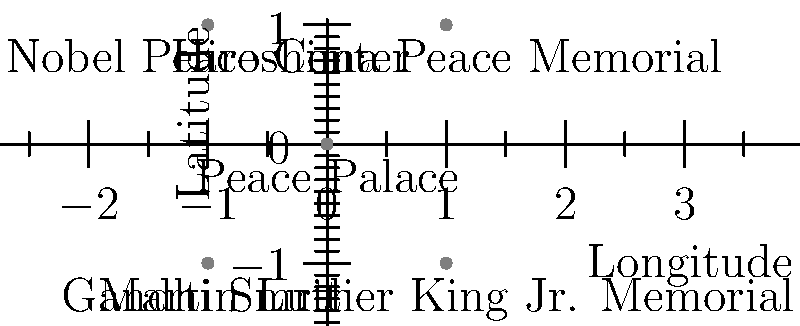Identify the landmark located at coordinates (0,0) on the graph, which is associated with international peace efforts and housed the Permanent Court of Arbitration. To answer this question, let's analyze the graph step-by-step:

1. The graph shows five landmarks associated with peace movements plotted on a coordinate system.
2. Each landmark is represented by a gray circle with its name labeled below.
3. We need to focus on the landmark at coordinates (0,0), which is at the origin of the graph.
4. The landmark at (0,0) is labeled "Peace Palace".
5. The Peace Palace, located in The Hague, Netherlands, is indeed associated with international peace efforts.
6. It houses the Permanent Court of Arbitration, as mentioned in the question, along with other international law organizations.
7. The Peace Palace was built to provide a symbolic home for the Permanent Court of Arbitration, established in 1899 to facilitate arbitration and other forms of dispute resolution between states.
8. Its construction was funded by American industrialist Andrew Carnegie, who was a prominent peace activist.
9. The Peace Palace continues to serve as a symbol of international justice and the peaceful resolution of conflicts.

Therefore, the landmark at coordinates (0,0) that fits the description in the question is the Peace Palace.
Answer: Peace Palace 